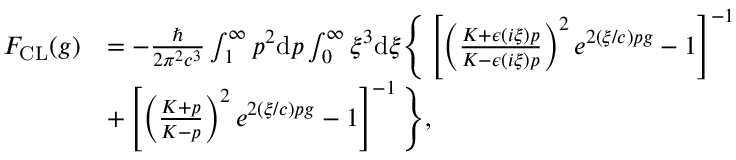<formula> <loc_0><loc_0><loc_500><loc_500>\begin{array} { r l } { F _ { C L } ( g ) } & { = - \frac { } { 2 \pi ^ { 2 } c ^ { 3 } } \int _ { 1 } ^ { \infty } p ^ { 2 } d p \int _ { 0 } ^ { \infty } \xi ^ { 3 } d \xi \left \{ \left [ \left ( \frac { K + \epsilon \left ( i \xi \right ) p } { K - \epsilon \left ( i \xi \right ) p } \right ) ^ { 2 } e ^ { 2 ( \xi / c ) p g } - 1 \right ] ^ { - 1 } } \\ & { + \left [ \left ( \frac { K + p } { K - p } \right ) ^ { 2 } e ^ { 2 ( \xi / c ) p g } - 1 \right ] ^ { - 1 } \right \} , } \end{array}</formula> 